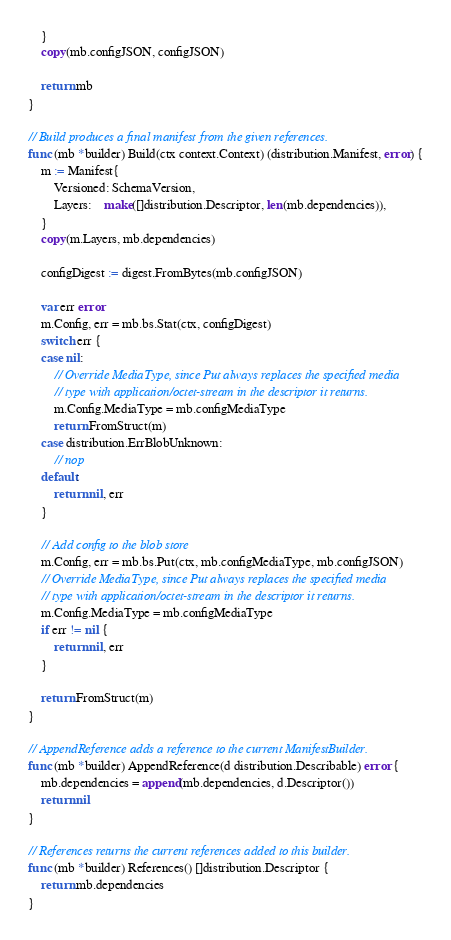<code> <loc_0><loc_0><loc_500><loc_500><_Go_>	}
	copy(mb.configJSON, configJSON)

	return mb
}

// Build produces a final manifest from the given references.
func (mb *builder) Build(ctx context.Context) (distribution.Manifest, error) {
	m := Manifest{
		Versioned: SchemaVersion,
		Layers:    make([]distribution.Descriptor, len(mb.dependencies)),
	}
	copy(m.Layers, mb.dependencies)

	configDigest := digest.FromBytes(mb.configJSON)

	var err error
	m.Config, err = mb.bs.Stat(ctx, configDigest)
	switch err {
	case nil:
		// Override MediaType, since Put always replaces the specified media
		// type with application/octet-stream in the descriptor it returns.
		m.Config.MediaType = mb.configMediaType
		return FromStruct(m)
	case distribution.ErrBlobUnknown:
		// nop
	default:
		return nil, err
	}

	// Add config to the blob store
	m.Config, err = mb.bs.Put(ctx, mb.configMediaType, mb.configJSON)
	// Override MediaType, since Put always replaces the specified media
	// type with application/octet-stream in the descriptor it returns.
	m.Config.MediaType = mb.configMediaType
	if err != nil {
		return nil, err
	}

	return FromStruct(m)
}

// AppendReference adds a reference to the current ManifestBuilder.
func (mb *builder) AppendReference(d distribution.Describable) error {
	mb.dependencies = append(mb.dependencies, d.Descriptor())
	return nil
}

// References returns the current references added to this builder.
func (mb *builder) References() []distribution.Descriptor {
	return mb.dependencies
}
</code> 